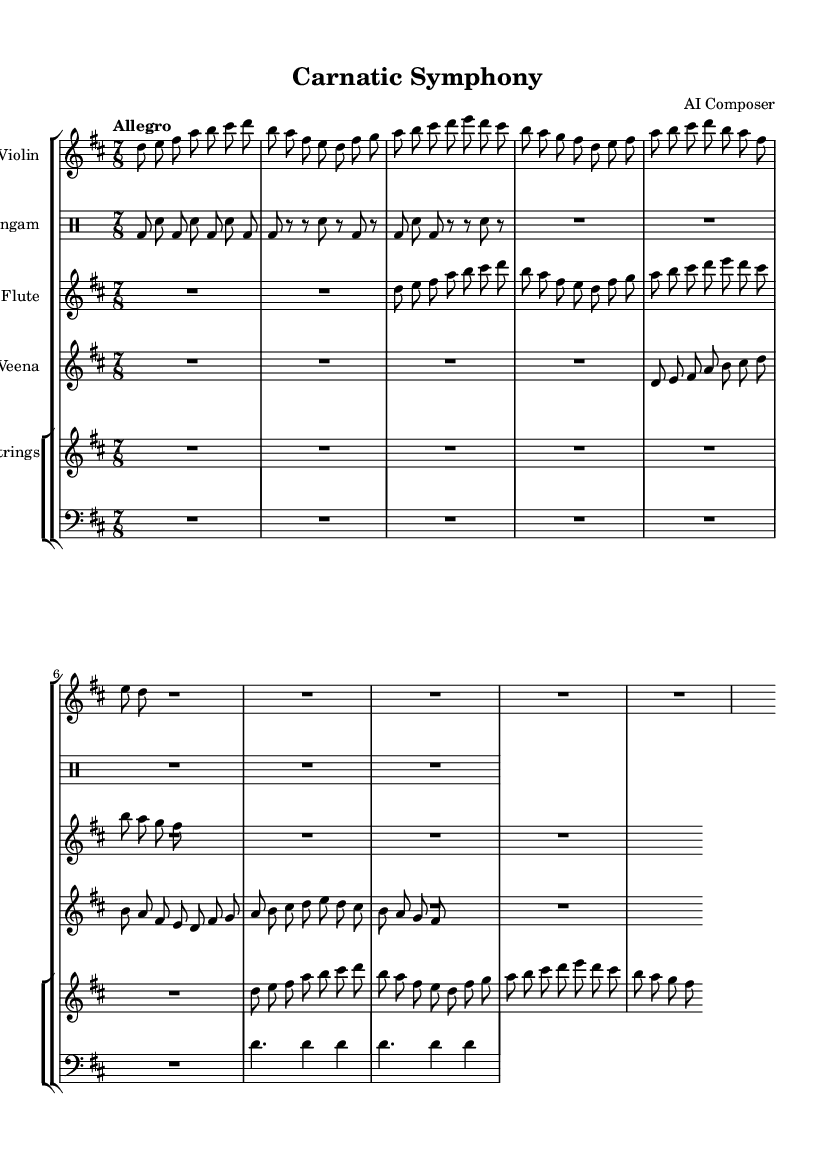what is the key signature of this music? The key signature is denoted by the key signature indicator, which shows 'D major', represented with two sharps (F# and C#).
Answer: D major what is the time signature of this music? The time signature is indicated at the beginning of the score, which shows '7/8', meaning there are seven eighth notes per measure.
Answer: 7/8 what is the tempo of this piece? The tempo marking is written above the staff and indicates 'Allegro', which suggests a lively and fast pace for the music.
Answer: Allegro how many measures does the violin music have? Counting the measures in the violin section, there are three complete measures before a rest that takes the whole bar, totaling four measures in this section.
Answer: 4 what instruments are featured in this symphony? By looking at the score, the instruments listed in the staff names are Violin, Mridangam, Flute, Veena, and Strings, indicating a combination of string and percussion instruments.
Answer: Violin, Mridangam, Flute, Veena, Strings which instrument plays the mridangam part? The music specifically labeled as 'Mridangam' is found in a drum staff and contains specific drum notations, clearly indicating which instrument is playing.
Answer: Mridangam how many beats are in the mridangam section? Each bar in the mridangam section counts the eighth notes, with seven eighth notes in each given bar according to the 7/8 time signature, resulting in a full measure count of nine beats in the section before concluding rests.
Answer: 9 